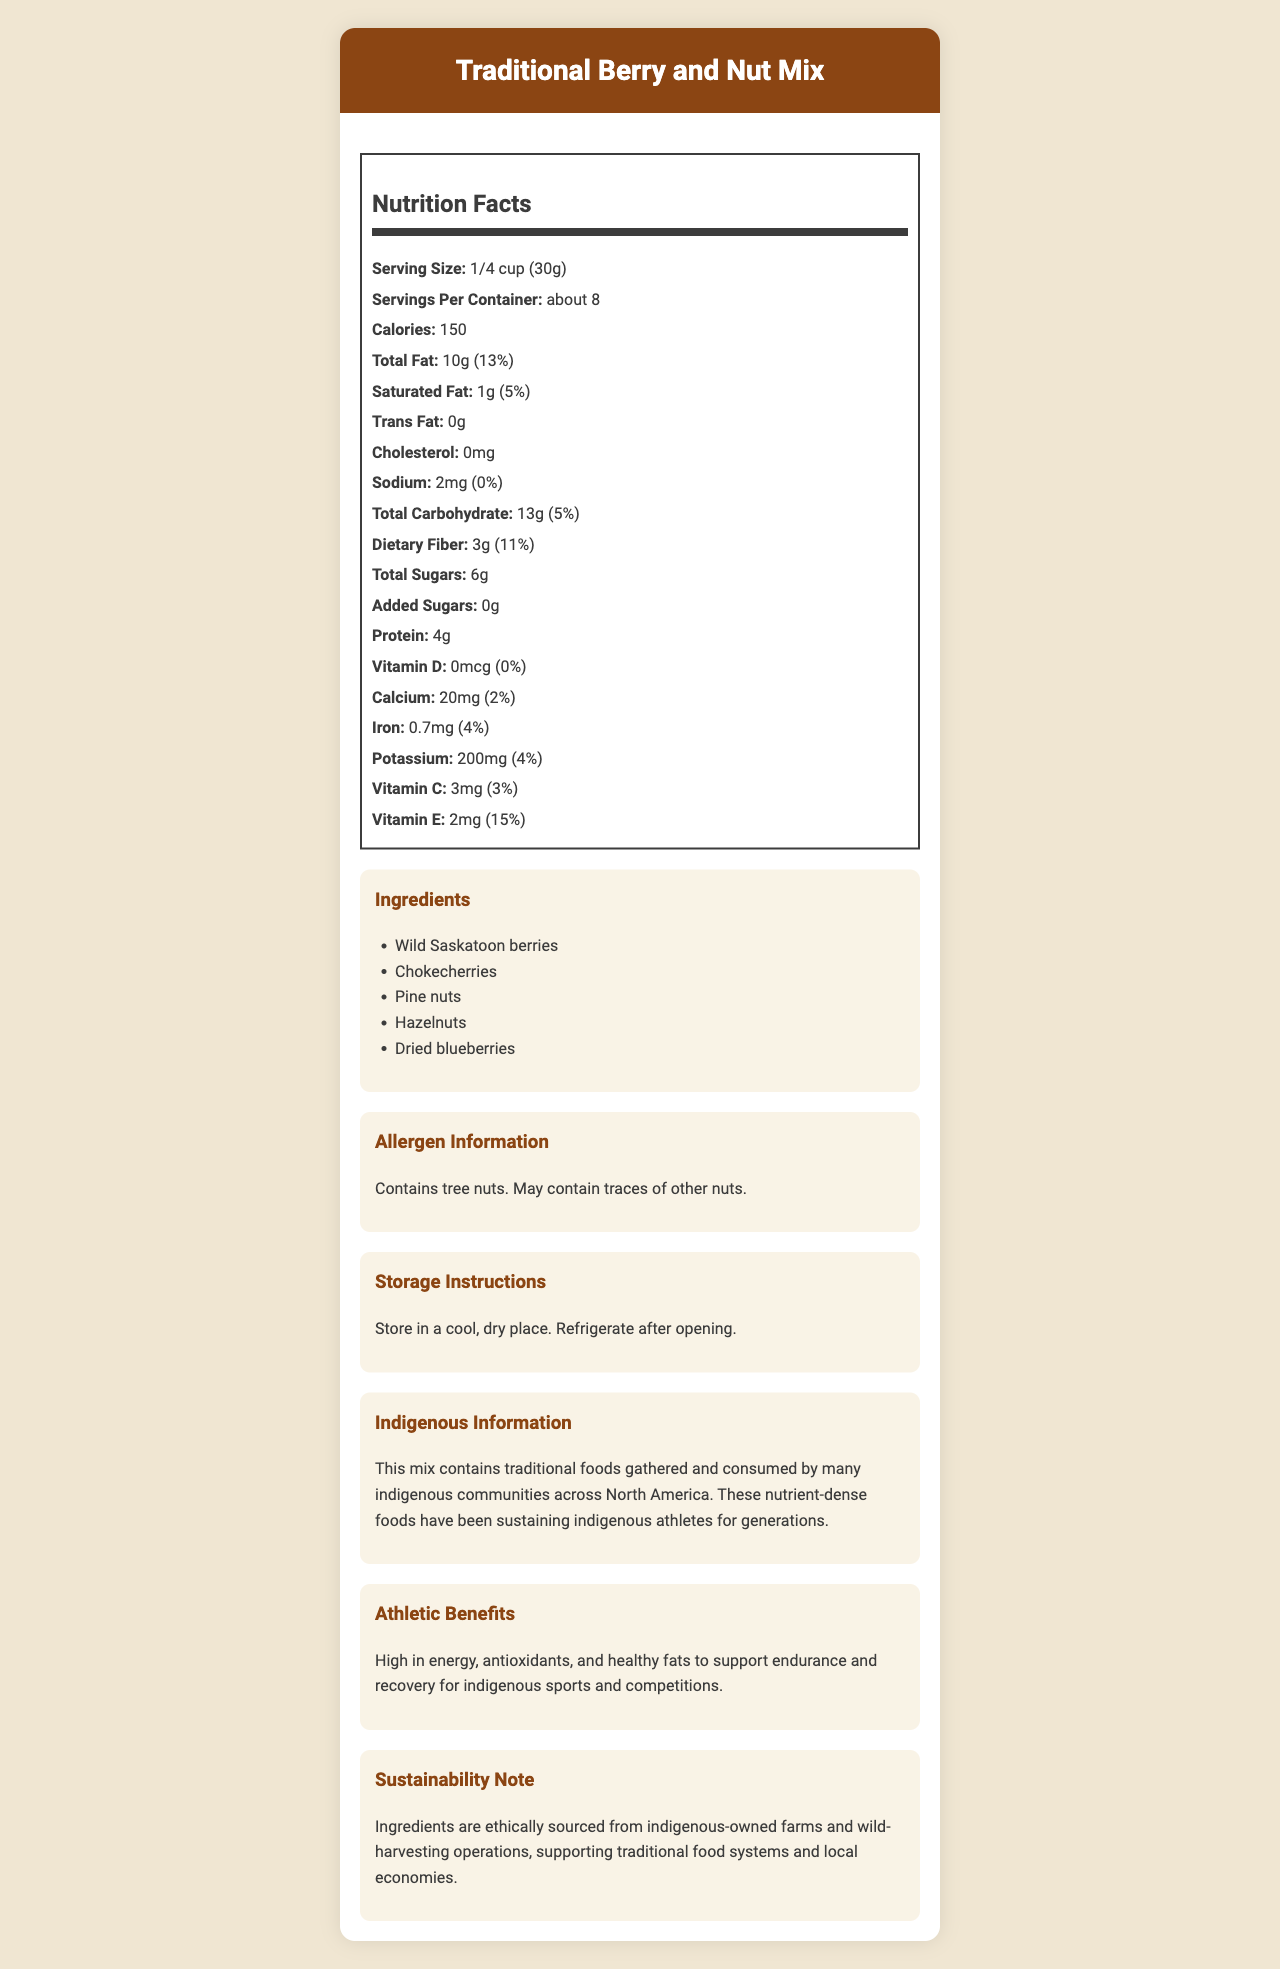what is the serving size? The serving size is clearly mentioned under the Nutrition Facts section.
Answer: 1/4 cup (30g) how many servings are in the container? The document specifies that there are about 8 servings per container in the Nutrition Facts section.
Answer: about 8 how many calories are in one serving? The number of calories per serving is listed as 150 in the Nutrition Facts section.
Answer: 150 how much total fat is in one serving? The total fat content per serving is indicated as 10g.
Answer: 10g what percentage of the daily value for total fat does one serving provide? The document mentions that one serving provides 13% of the daily value for total fat.
Answer: 13% how much dietary fiber is in one serving? The document lists the dietary fiber content as 3g per serving.
Answer: 3g what is the percentage of the daily value for dietary fiber? The daily value for dietary fiber is 11% per serving, as listed.
Answer: 11% which ingredient is not a nut? A. Pine nuts B. Hazelnuts C. Dried blueberries D. Wild Saskatoon berries Both A and B are nuts, but C dried blueberries is not a nut, it is a berry.
Answer: C what is the sodium content in one serving? The sodium content per serving is mentioned as 2mg.
Answer: 2mg what should you do with the product after opening? A. Freeze it B. Keep it in a cool place C. Refrigerate it The storage instructions specifically state to refrigerate the product after opening.
Answer: C is there any added sugar in the product? The document states that there are 0g of added sugars.
Answer: No how much potassium is in one serving? The potassium content per serving is listed as 200mg.
Answer: 200mg does this product contain tree nuts? The allergen information indicates that the product contains tree nuts.
Answer: Yes how should the product be stored before opening? The storage instructions specify to store the product in a cool, dry place before opening.
Answer: Store in a cool, dry place are there any trans fats in the product? The document states that there are 0g of trans fats in the product.
Answer: No describe the main idea of this document. The document aims to provide comprehensive information about the Traditional Berry and Nut Mix, including its nutritional facts, ingredients, and benefits for indigenous athletes. It also emphasizes sustainable practices and traditional food sources.
Answer: The document provides detailed nutritional information, ingredient list, allergen information, storage instructions, and additional insights about a Traditional Berry and Nut Mix. It highlights the product's benefits for indigenous athletes, its ethical sourcing, and its significance in indigenous diets. how many vitamins are present in the product? The nutrition label lists Vitamin D, Calcium, Iron, Potassium, Vitamin C, and Vitamin E.
Answer: Five (Vitamin D, Calcium, Iron, Potassium, Vitamin C, Vitamin E) does the product contain any cholesterol? The document states that the product contains 0mg of cholesterol.
Answer: No does the mix contain any ingredients sourced from indigenous-owned farms? The sustainability note mentions that ingredients are ethically sourced from indigenous-owned farms.
Answer: Yes where did chokecherries originate? The document does not provide information about the origin of chokecherries specifically.
Answer: Not enough information 